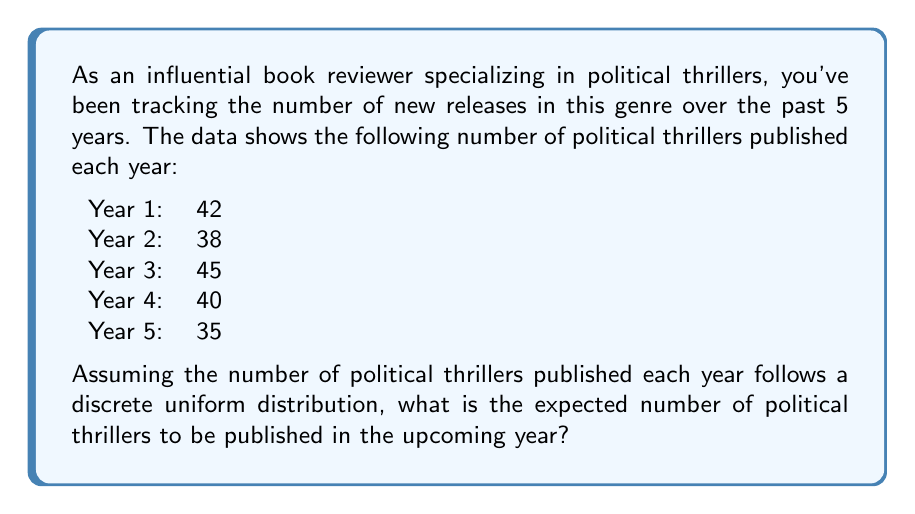Can you solve this math problem? To solve this problem, we need to follow these steps:

1. Identify the random variable:
   Let $X$ be the number of political thrillers published in a year.

2. Determine the possible values of $X$:
   The possible values are the observed numbers from the past 5 years: 35, 38, 40, 42, and 45.

3. Assume a discrete uniform distribution:
   This means each value has an equal probability of occurring.

4. Calculate the probability of each value:
   With 5 possible values, the probability of each is $\frac{1}{5}$.

5. Calculate the expected value:
   The expected value of a discrete random variable is given by:
   
   $$E(X) = \sum_{i=1}^{n} x_i \cdot p(x_i)$$
   
   Where $x_i$ are the possible values and $p(x_i)$ is the probability of each value.

6. Substitute the values:
   $$E(X) = 35 \cdot \frac{1}{5} + 38 \cdot \frac{1}{5} + 40 \cdot \frac{1}{5} + 42 \cdot \frac{1}{5} + 45 \cdot \frac{1}{5}$$

7. Simplify:
   $$E(X) = \frac{35 + 38 + 40 + 42 + 45}{5} = \frac{200}{5} = 40$$

Therefore, the expected number of political thrillers to be published in the upcoming year is 40.
Answer: 40 political thrillers 